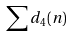<formula> <loc_0><loc_0><loc_500><loc_500>\sum d _ { 4 } ( n )</formula> 